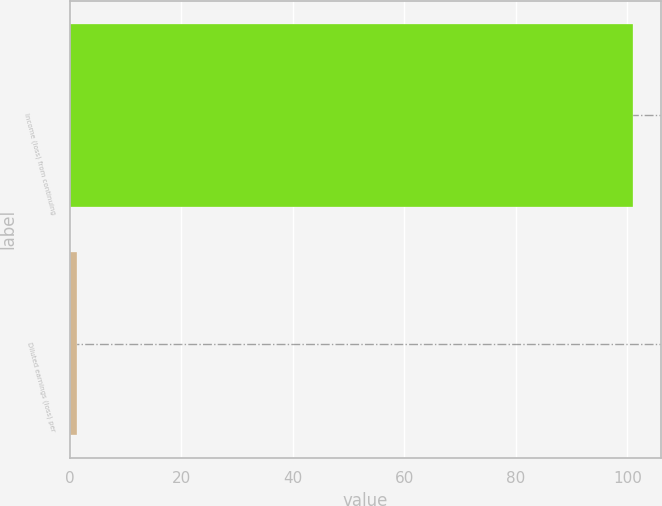Convert chart. <chart><loc_0><loc_0><loc_500><loc_500><bar_chart><fcel>Income (loss) from continuing<fcel>Diluted earnings (loss) per<nl><fcel>101<fcel>1.38<nl></chart> 